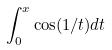<formula> <loc_0><loc_0><loc_500><loc_500>\int _ { 0 } ^ { x } \cos ( 1 / t ) d t</formula> 